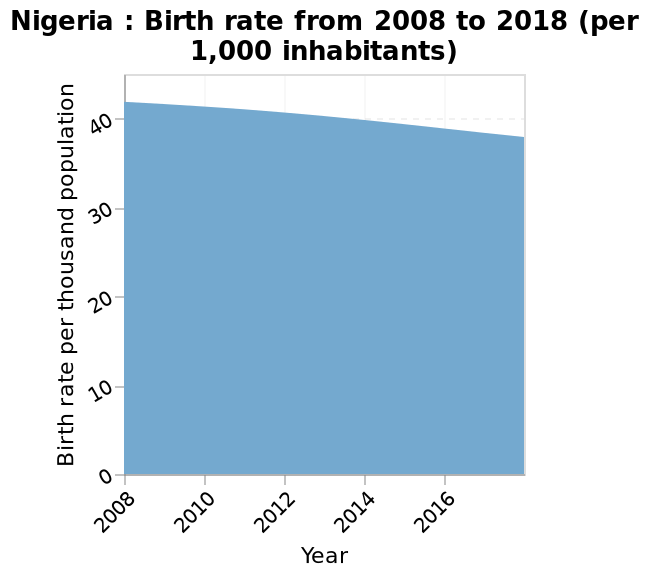<image>
Offer a thorough analysis of the image. The birth rate in Nigeria has been decreasing since the start of the information and seems to be decreasing at a faster ratee as time goes by. How has the birth rate changed since the start of the chart?  The birth rate has gone down since the beginning of the chart. Is the birth rate higher or lower now compared to the start of the chart? The birth rate is lower now compared to the start of the chart. What country does the area plot depict? The area plot depicts the birth rate in Nigeria from 2008 to 2018. What has been happening to the birth rate since the beginning of the chart?  The birth rate has been decreasing since the start of the chart. What is being represented on the x-axis of the plot? The x-axis of the plot represents the years from 2008 to 2018. Has the birth rate been increasing since the start of the chart? No. The birth rate has been decreasing since the start of the chart. 